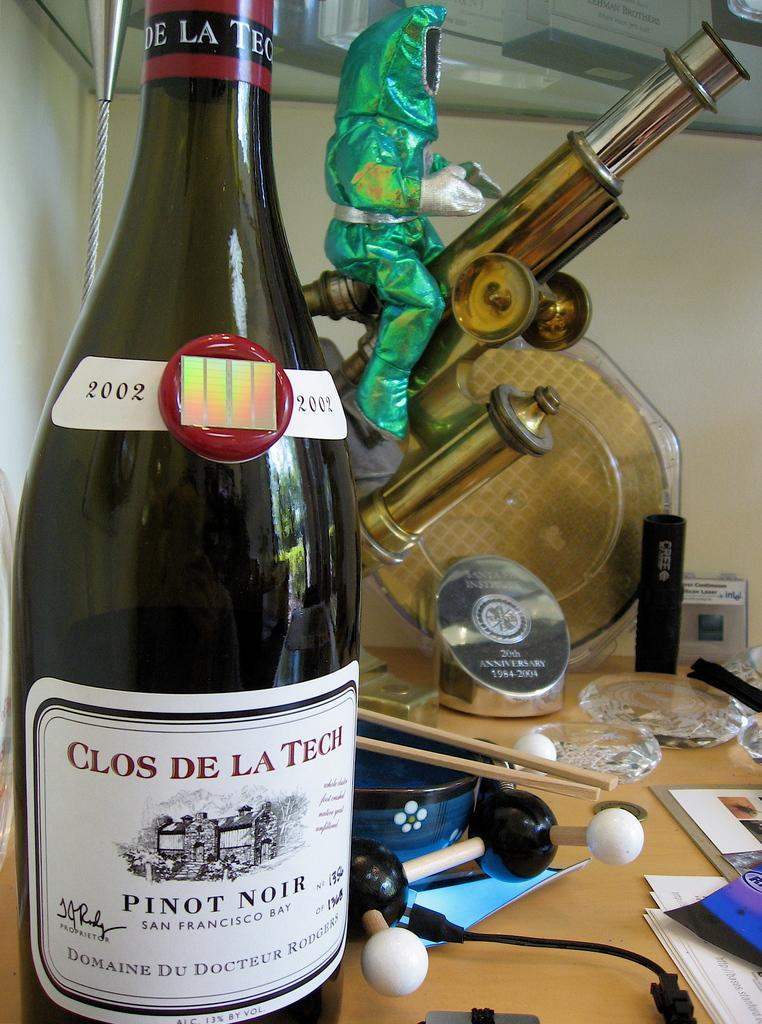<image>
Create a compact narrative representing the image presented. A bottle of Clos de la Teche branded Pinot Noir. 